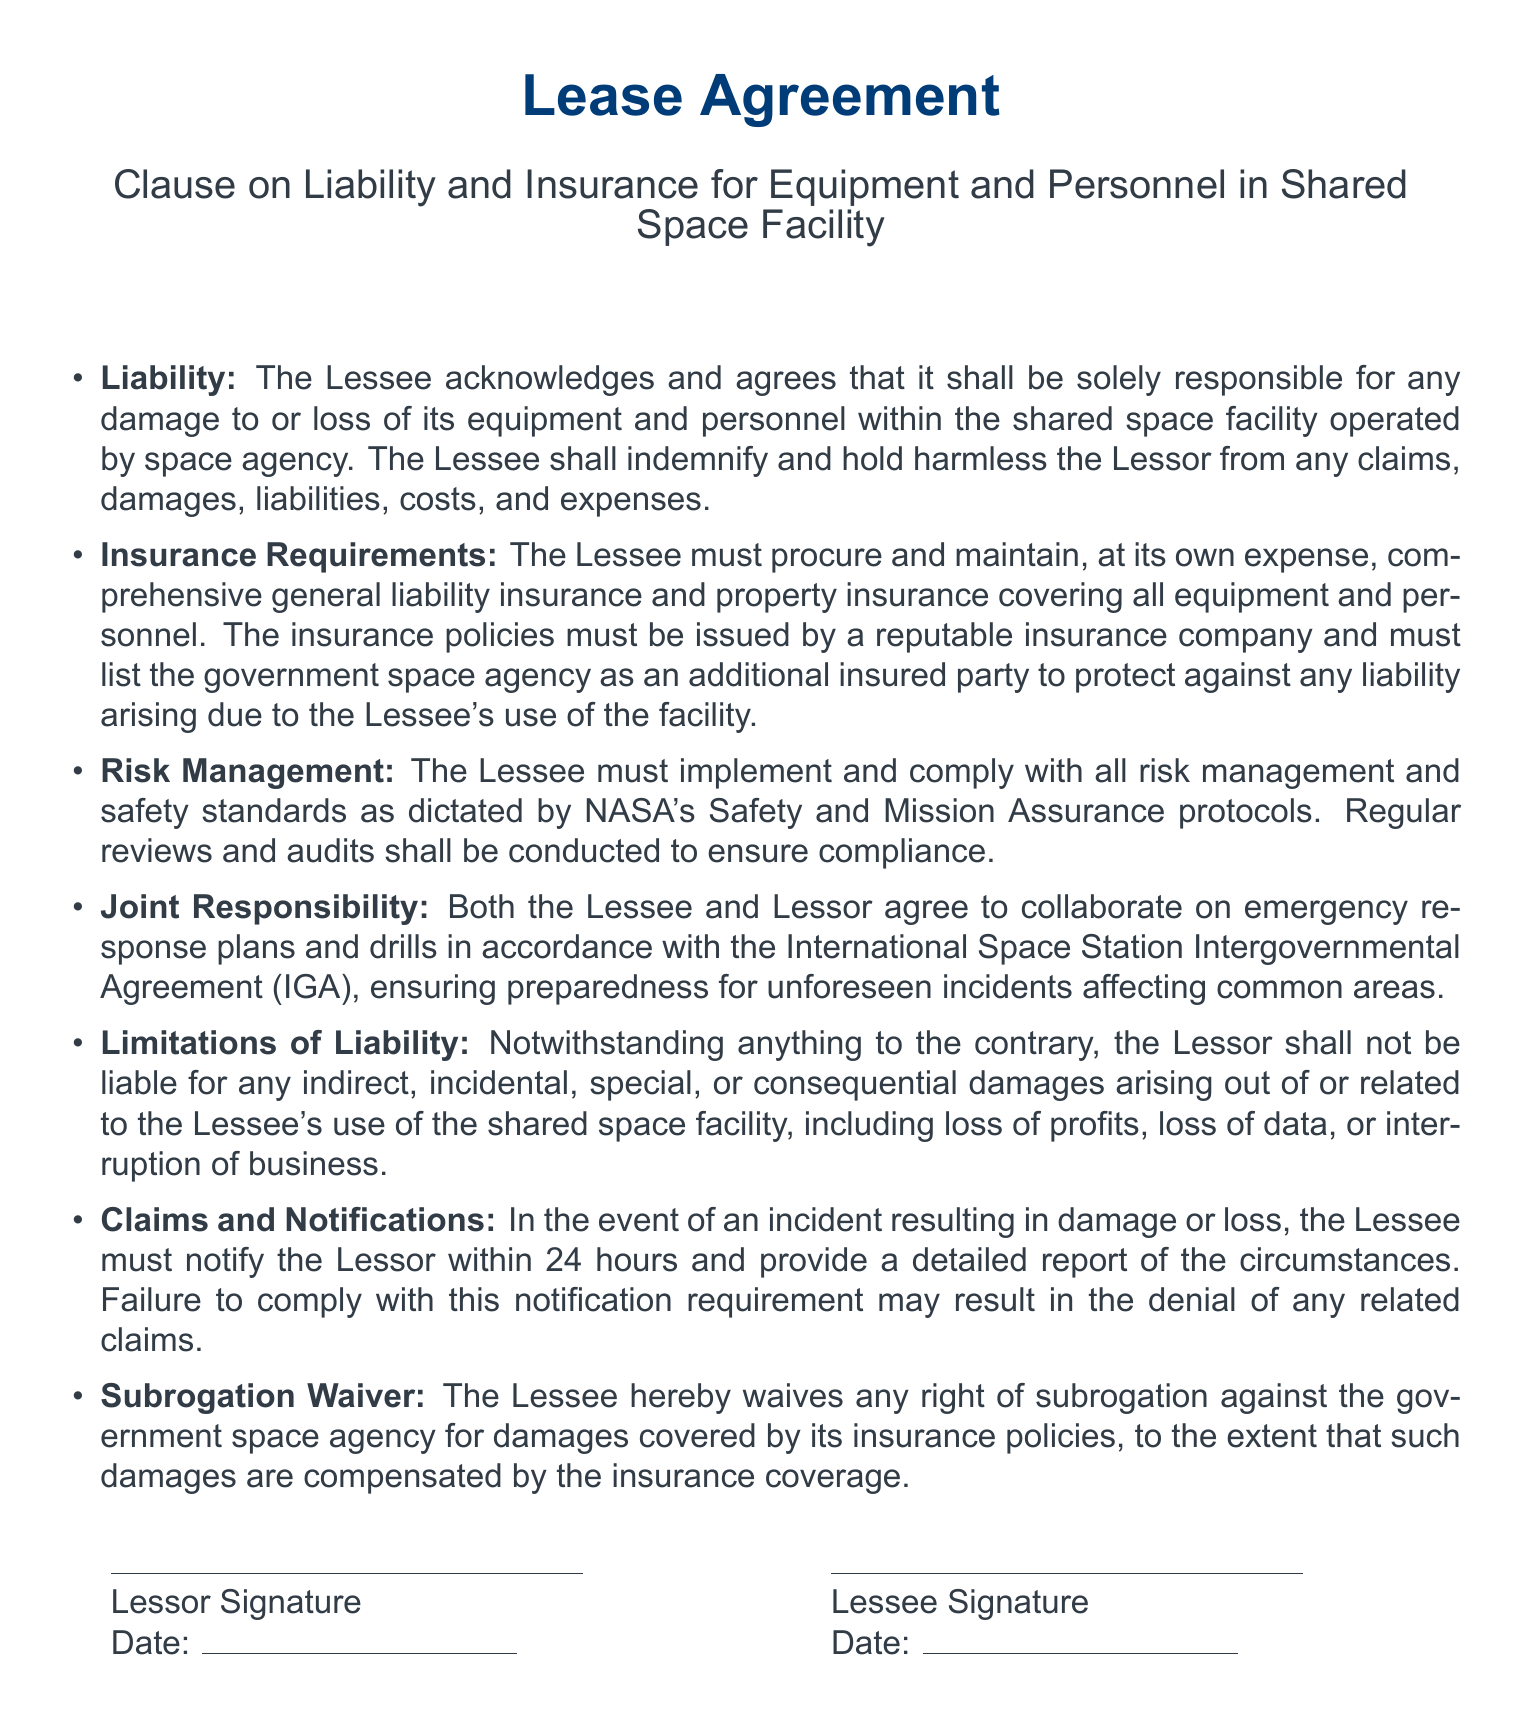What is the Lessee's responsibility regarding equipment damage? The Lessee is solely responsible for any damage to or loss of its equipment and personnel within the shared space facility.
Answer: Solely responsible What must the Lessee procure and maintain? The Lessee must procure and maintain comprehensive general liability insurance and property insurance covering all equipment and personnel.
Answer: Insurance Which protocols must the Lessee comply with for risk management? The Lessee must comply with NASA's Safety and Mission Assurance protocols.
Answer: NASA's Safety and Mission Assurance What is the time frame for the Lessee to notify the Lessor of an incident? The Lessee must notify the Lessor within 24 hours.
Answer: 24 hours What does the Subrogation Waiver entail? The Lessee waives any right of subrogation against the government space agency for damages covered by its insurance policies.
Answer: Waiver of subrogation What types of damages is the Lessor not liable for? The Lessor is not liable for any indirect, incidental, special, or consequential damages.
Answer: Indirect, incidental, special, consequential What agreement relates to emergency response plans? The Lessee and Lessor agree to collaborate on emergency response plans according to the International Space Station Intergovernmental Agreement (IGA).
Answer: IGA What must be included in the insurance policies? The insurance policies must list the government space agency as an additional insured party.
Answer: Additional insured party 